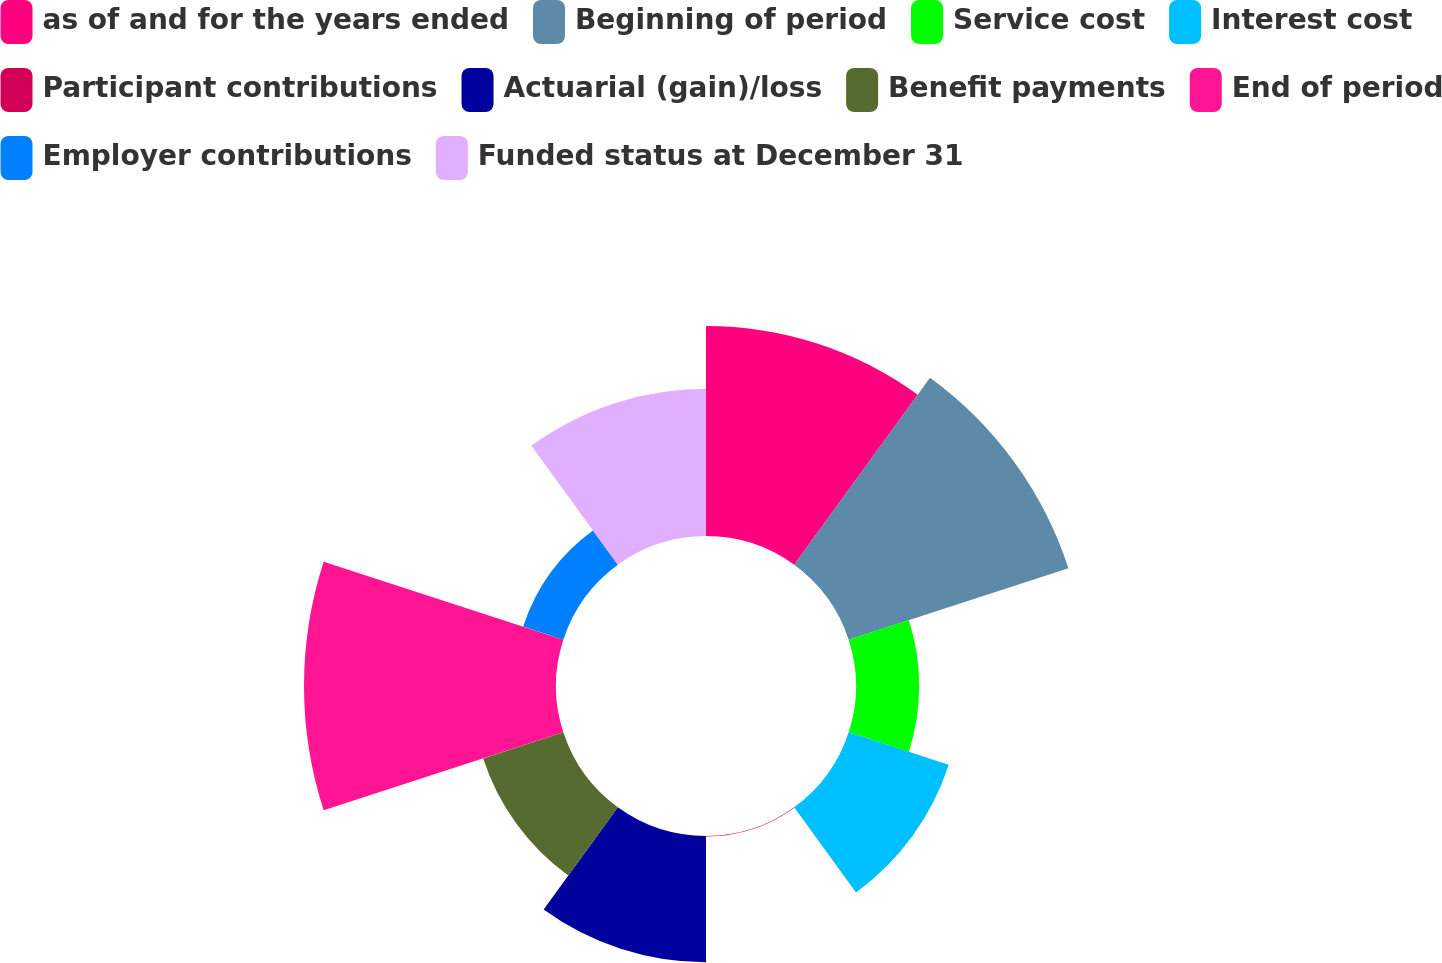Convert chart. <chart><loc_0><loc_0><loc_500><loc_500><pie_chart><fcel>as of and for the years ended<fcel>Beginning of period<fcel>Service cost<fcel>Interest cost<fcel>Participant contributions<fcel>Actuarial (gain)/loss<fcel>Benefit payments<fcel>End of period<fcel>Employer contributions<fcel>Funded status at December 31<nl><fcel>16.65%<fcel>18.31%<fcel>5.01%<fcel>8.34%<fcel>0.03%<fcel>10.0%<fcel>6.68%<fcel>19.97%<fcel>3.35%<fcel>11.66%<nl></chart> 